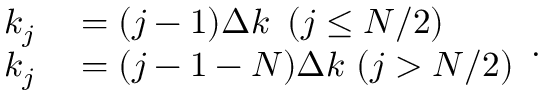Convert formula to latex. <formula><loc_0><loc_0><loc_500><loc_500>\begin{array} { r } { \begin{array} { r l } { k _ { j } } & = ( j - 1 ) \Delta k \, ( j \leq N / 2 ) } \\ { k _ { j } } & = ( j - 1 - N ) \Delta k \, ( j > N / 2 ) } \end{array} . } \end{array}</formula> 